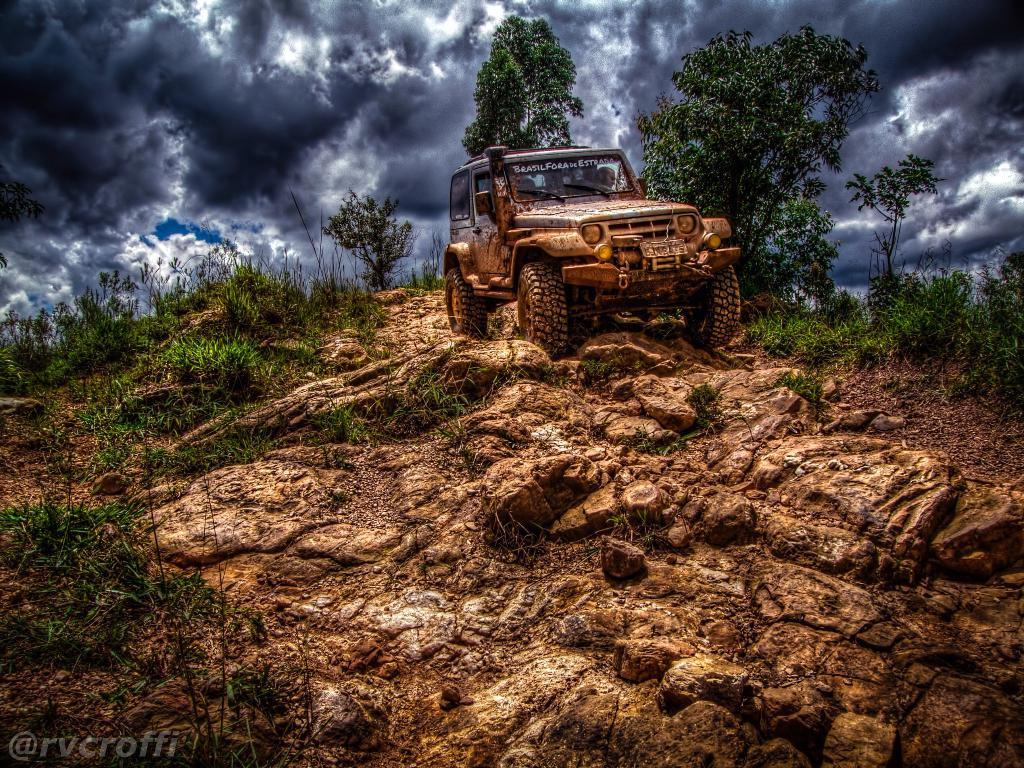What is the main subject in the image? There is a vehicle in the image. What type of natural environment is visible in the image? There is grass, plants, trees, and the sky with clouds visible in the image. Can you describe the background of the image? The sky with clouds is visible in the background of the image. Is there any text or marking in the image? Yes, there is a watermark in the bottom left side of the image. How does the mother use the cloth in the image? There is no mother or cloth present in the image. 